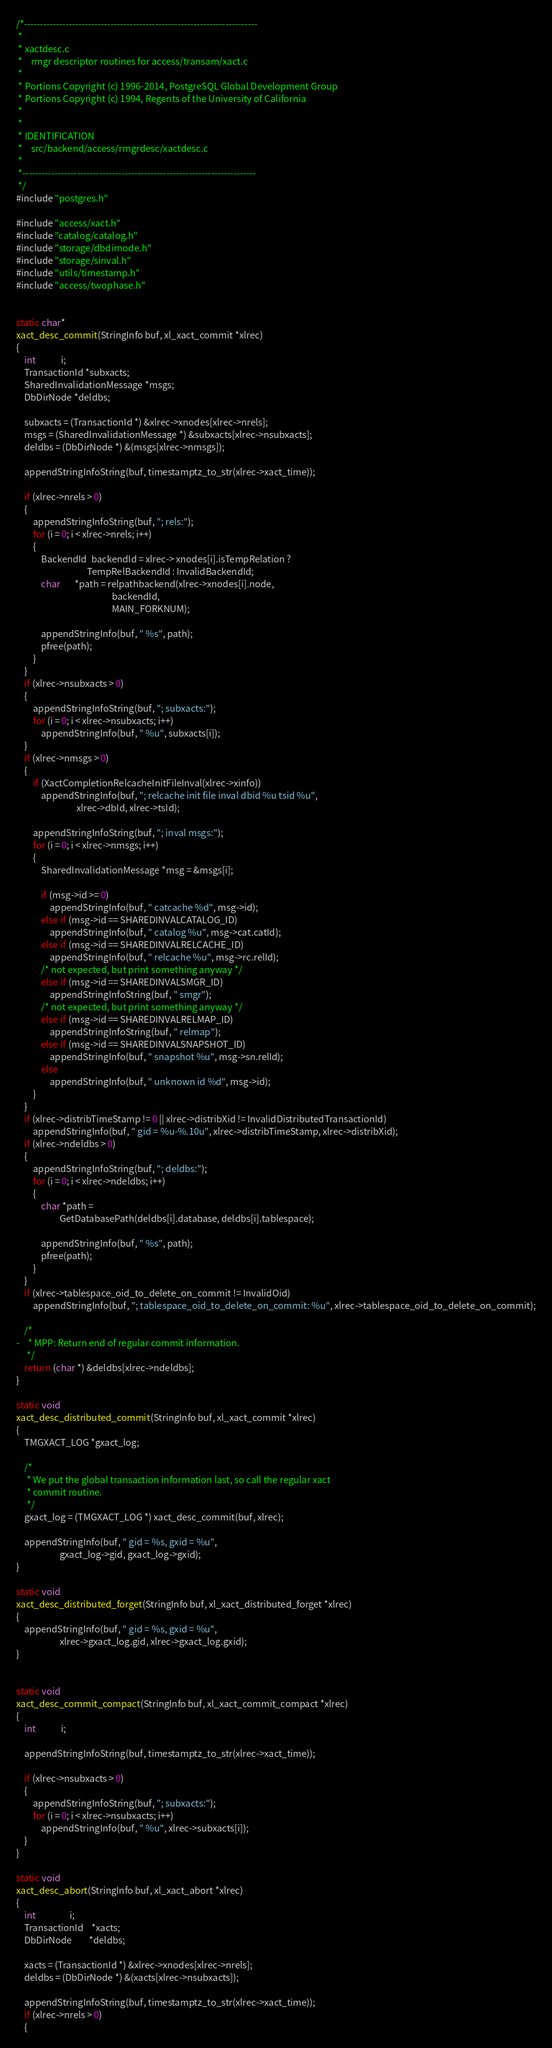Convert code to text. <code><loc_0><loc_0><loc_500><loc_500><_C_>/*-------------------------------------------------------------------------
 *
 * xactdesc.c
 *	  rmgr descriptor routines for access/transam/xact.c
 *
 * Portions Copyright (c) 1996-2014, PostgreSQL Global Development Group
 * Portions Copyright (c) 1994, Regents of the University of California
 *
 *
 * IDENTIFICATION
 *	  src/backend/access/rmgrdesc/xactdesc.c
 *
 *-------------------------------------------------------------------------
 */
#include "postgres.h"

#include "access/xact.h"
#include "catalog/catalog.h"
#include "storage/dbdirnode.h"
#include "storage/sinval.h"
#include "utils/timestamp.h"
#include "access/twophase.h"


static char*
xact_desc_commit(StringInfo buf, xl_xact_commit *xlrec)
{
	int			i;
	TransactionId *subxacts;
	SharedInvalidationMessage *msgs;
	DbDirNode *deldbs;

	subxacts = (TransactionId *) &xlrec->xnodes[xlrec->nrels];
	msgs = (SharedInvalidationMessage *) &subxacts[xlrec->nsubxacts];
	deldbs = (DbDirNode *) &(msgs[xlrec->nmsgs]);

	appendStringInfoString(buf, timestamptz_to_str(xlrec->xact_time));

	if (xlrec->nrels > 0)
	{
		appendStringInfoString(buf, "; rels:");
		for (i = 0; i < xlrec->nrels; i++)
		{
			BackendId  backendId = xlrec-> xnodes[i].isTempRelation ?
								  TempRelBackendId : InvalidBackendId;
			char	   *path = relpathbackend(xlrec->xnodes[i].node,
											  backendId,
											  MAIN_FORKNUM);

			appendStringInfo(buf, " %s", path);
			pfree(path);
		}
	}
	if (xlrec->nsubxacts > 0)
	{
		appendStringInfoString(buf, "; subxacts:");
		for (i = 0; i < xlrec->nsubxacts; i++)
			appendStringInfo(buf, " %u", subxacts[i]);
	}
	if (xlrec->nmsgs > 0)
	{
		if (XactCompletionRelcacheInitFileInval(xlrec->xinfo))
			appendStringInfo(buf, "; relcache init file inval dbid %u tsid %u",
							 xlrec->dbId, xlrec->tsId);

		appendStringInfoString(buf, "; inval msgs:");
		for (i = 0; i < xlrec->nmsgs; i++)
		{
			SharedInvalidationMessage *msg = &msgs[i];

			if (msg->id >= 0)
				appendStringInfo(buf, " catcache %d", msg->id);
			else if (msg->id == SHAREDINVALCATALOG_ID)
				appendStringInfo(buf, " catalog %u", msg->cat.catId);
			else if (msg->id == SHAREDINVALRELCACHE_ID)
				appendStringInfo(buf, " relcache %u", msg->rc.relId);
			/* not expected, but print something anyway */
			else if (msg->id == SHAREDINVALSMGR_ID)
				appendStringInfoString(buf, " smgr");
			/* not expected, but print something anyway */
			else if (msg->id == SHAREDINVALRELMAP_ID)
				appendStringInfoString(buf, " relmap");
			else if (msg->id == SHAREDINVALSNAPSHOT_ID)
				appendStringInfo(buf, " snapshot %u", msg->sn.relId);
			else
				appendStringInfo(buf, " unknown id %d", msg->id);
		}
	}
	if (xlrec->distribTimeStamp != 0 || xlrec->distribXid != InvalidDistributedTransactionId)
		appendStringInfo(buf, " gid = %u-%.10u", xlrec->distribTimeStamp, xlrec->distribXid);
	if (xlrec->ndeldbs > 0)
	{
		appendStringInfoString(buf, "; deldbs:");
		for (i = 0; i < xlrec->ndeldbs; i++)
		{
			char *path =
					 GetDatabasePath(deldbs[i].database, deldbs[i].tablespace);

			appendStringInfo(buf, " %s", path);
			pfree(path);
		}
	}
	if (xlrec->tablespace_oid_to_delete_on_commit != InvalidOid)
		appendStringInfo(buf, "; tablespace_oid_to_delete_on_commit: %u", xlrec->tablespace_oid_to_delete_on_commit);

	/*
-	 * MPP: Return end of regular commit information.
	 */
	return (char *) &deldbs[xlrec->ndeldbs];
}

static void
xact_desc_distributed_commit(StringInfo buf, xl_xact_commit *xlrec)
{
	TMGXACT_LOG *gxact_log;

	/*
	 * We put the global transaction information last, so call the regular xact
	 * commit routine.
	 */
	gxact_log = (TMGXACT_LOG *) xact_desc_commit(buf, xlrec);

	appendStringInfo(buf, " gid = %s, gxid = %u",
					 gxact_log->gid, gxact_log->gxid);
}

static void
xact_desc_distributed_forget(StringInfo buf, xl_xact_distributed_forget *xlrec)
{
	appendStringInfo(buf, " gid = %s, gxid = %u",
					 xlrec->gxact_log.gid, xlrec->gxact_log.gxid);
}


static void
xact_desc_commit_compact(StringInfo buf, xl_xact_commit_compact *xlrec)
{
	int			i;

	appendStringInfoString(buf, timestamptz_to_str(xlrec->xact_time));

	if (xlrec->nsubxacts > 0)
	{
		appendStringInfoString(buf, "; subxacts:");
		for (i = 0; i < xlrec->nsubxacts; i++)
			appendStringInfo(buf, " %u", xlrec->subxacts[i]);
	}
}

static void
xact_desc_abort(StringInfo buf, xl_xact_abort *xlrec)
{
	int				i;
	TransactionId	*xacts;
	DbDirNode		*deldbs;

	xacts = (TransactionId *) &xlrec->xnodes[xlrec->nrels];
	deldbs = (DbDirNode *) &(xacts[xlrec->nsubxacts]);

	appendStringInfoString(buf, timestamptz_to_str(xlrec->xact_time));
	if (xlrec->nrels > 0)
	{</code> 